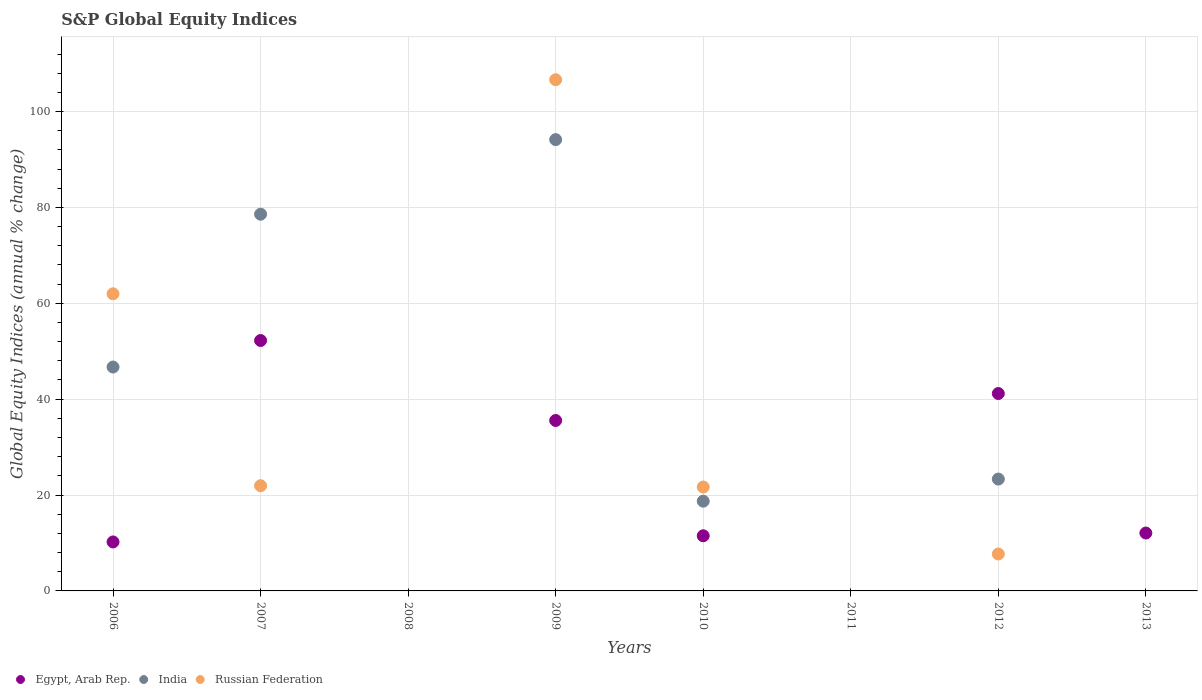Is the number of dotlines equal to the number of legend labels?
Offer a very short reply. No. What is the global equity indices in Russian Federation in 2007?
Give a very brief answer. 21.94. Across all years, what is the maximum global equity indices in Russian Federation?
Ensure brevity in your answer.  106.63. What is the total global equity indices in India in the graph?
Your answer should be very brief. 261.48. What is the difference between the global equity indices in Egypt, Arab Rep. in 2010 and that in 2012?
Your answer should be compact. -29.68. What is the difference between the global equity indices in Russian Federation in 2011 and the global equity indices in India in 2012?
Offer a terse response. -23.33. What is the average global equity indices in Egypt, Arab Rep. per year?
Your answer should be very brief. 20.35. In the year 2010, what is the difference between the global equity indices in India and global equity indices in Russian Federation?
Offer a terse response. -2.95. What is the ratio of the global equity indices in India in 2006 to that in 2009?
Make the answer very short. 0.5. Is the global equity indices in Egypt, Arab Rep. in 2009 less than that in 2013?
Keep it short and to the point. No. Is the difference between the global equity indices in India in 2006 and 2009 greater than the difference between the global equity indices in Russian Federation in 2006 and 2009?
Offer a very short reply. No. What is the difference between the highest and the second highest global equity indices in Russian Federation?
Give a very brief answer. 44.65. What is the difference between the highest and the lowest global equity indices in Russian Federation?
Ensure brevity in your answer.  106.63. Is the sum of the global equity indices in Egypt, Arab Rep. in 2010 and 2012 greater than the maximum global equity indices in Russian Federation across all years?
Provide a short and direct response. No. Is it the case that in every year, the sum of the global equity indices in India and global equity indices in Russian Federation  is greater than the global equity indices in Egypt, Arab Rep.?
Offer a very short reply. No. Is the global equity indices in Egypt, Arab Rep. strictly greater than the global equity indices in India over the years?
Offer a terse response. No. Is the global equity indices in India strictly less than the global equity indices in Egypt, Arab Rep. over the years?
Offer a terse response. No. How many dotlines are there?
Make the answer very short. 3. How many years are there in the graph?
Keep it short and to the point. 8. What is the difference between two consecutive major ticks on the Y-axis?
Give a very brief answer. 20. Are the values on the major ticks of Y-axis written in scientific E-notation?
Provide a succinct answer. No. Does the graph contain any zero values?
Ensure brevity in your answer.  Yes. How many legend labels are there?
Keep it short and to the point. 3. What is the title of the graph?
Offer a terse response. S&P Global Equity Indices. Does "Zambia" appear as one of the legend labels in the graph?
Make the answer very short. No. What is the label or title of the Y-axis?
Your answer should be very brief. Global Equity Indices (annual % change). What is the Global Equity Indices (annual % change) in Egypt, Arab Rep. in 2006?
Your response must be concise. 10.22. What is the Global Equity Indices (annual % change) in India in 2006?
Make the answer very short. 46.7. What is the Global Equity Indices (annual % change) in Russian Federation in 2006?
Provide a short and direct response. 61.98. What is the Global Equity Indices (annual % change) of Egypt, Arab Rep. in 2007?
Give a very brief answer. 52.24. What is the Global Equity Indices (annual % change) of India in 2007?
Offer a very short reply. 78.58. What is the Global Equity Indices (annual % change) of Russian Federation in 2007?
Offer a very short reply. 21.94. What is the Global Equity Indices (annual % change) in India in 2008?
Make the answer very short. 0. What is the Global Equity Indices (annual % change) in Egypt, Arab Rep. in 2009?
Ensure brevity in your answer.  35.55. What is the Global Equity Indices (annual % change) in India in 2009?
Your answer should be very brief. 94.14. What is the Global Equity Indices (annual % change) in Russian Federation in 2009?
Give a very brief answer. 106.63. What is the Global Equity Indices (annual % change) of Egypt, Arab Rep. in 2010?
Provide a short and direct response. 11.5. What is the Global Equity Indices (annual % change) of India in 2010?
Your response must be concise. 18.72. What is the Global Equity Indices (annual % change) in Russian Federation in 2010?
Give a very brief answer. 21.67. What is the Global Equity Indices (annual % change) in India in 2011?
Ensure brevity in your answer.  0. What is the Global Equity Indices (annual % change) in Egypt, Arab Rep. in 2012?
Offer a very short reply. 41.18. What is the Global Equity Indices (annual % change) in India in 2012?
Your response must be concise. 23.33. What is the Global Equity Indices (annual % change) of Russian Federation in 2012?
Give a very brief answer. 7.7. What is the Global Equity Indices (annual % change) of Egypt, Arab Rep. in 2013?
Offer a terse response. 12.08. What is the Global Equity Indices (annual % change) of India in 2013?
Give a very brief answer. 0. Across all years, what is the maximum Global Equity Indices (annual % change) of Egypt, Arab Rep.?
Offer a terse response. 52.24. Across all years, what is the maximum Global Equity Indices (annual % change) in India?
Provide a succinct answer. 94.14. Across all years, what is the maximum Global Equity Indices (annual % change) of Russian Federation?
Provide a short and direct response. 106.63. Across all years, what is the minimum Global Equity Indices (annual % change) of India?
Provide a short and direct response. 0. Across all years, what is the minimum Global Equity Indices (annual % change) in Russian Federation?
Ensure brevity in your answer.  0. What is the total Global Equity Indices (annual % change) of Egypt, Arab Rep. in the graph?
Your answer should be compact. 162.77. What is the total Global Equity Indices (annual % change) in India in the graph?
Provide a short and direct response. 261.48. What is the total Global Equity Indices (annual % change) in Russian Federation in the graph?
Your answer should be compact. 219.93. What is the difference between the Global Equity Indices (annual % change) of Egypt, Arab Rep. in 2006 and that in 2007?
Ensure brevity in your answer.  -42.02. What is the difference between the Global Equity Indices (annual % change) of India in 2006 and that in 2007?
Keep it short and to the point. -31.88. What is the difference between the Global Equity Indices (annual % change) in Russian Federation in 2006 and that in 2007?
Offer a terse response. 40.04. What is the difference between the Global Equity Indices (annual % change) of Egypt, Arab Rep. in 2006 and that in 2009?
Give a very brief answer. -25.34. What is the difference between the Global Equity Indices (annual % change) of India in 2006 and that in 2009?
Make the answer very short. -47.44. What is the difference between the Global Equity Indices (annual % change) in Russian Federation in 2006 and that in 2009?
Your answer should be very brief. -44.65. What is the difference between the Global Equity Indices (annual % change) of Egypt, Arab Rep. in 2006 and that in 2010?
Your response must be concise. -1.28. What is the difference between the Global Equity Indices (annual % change) in India in 2006 and that in 2010?
Your answer should be very brief. 27.98. What is the difference between the Global Equity Indices (annual % change) in Russian Federation in 2006 and that in 2010?
Offer a very short reply. 40.31. What is the difference between the Global Equity Indices (annual % change) in Egypt, Arab Rep. in 2006 and that in 2012?
Provide a succinct answer. -30.96. What is the difference between the Global Equity Indices (annual % change) of India in 2006 and that in 2012?
Keep it short and to the point. 23.37. What is the difference between the Global Equity Indices (annual % change) of Russian Federation in 2006 and that in 2012?
Offer a terse response. 54.28. What is the difference between the Global Equity Indices (annual % change) of Egypt, Arab Rep. in 2006 and that in 2013?
Provide a succinct answer. -1.86. What is the difference between the Global Equity Indices (annual % change) of Egypt, Arab Rep. in 2007 and that in 2009?
Ensure brevity in your answer.  16.68. What is the difference between the Global Equity Indices (annual % change) of India in 2007 and that in 2009?
Make the answer very short. -15.56. What is the difference between the Global Equity Indices (annual % change) in Russian Federation in 2007 and that in 2009?
Offer a very short reply. -84.69. What is the difference between the Global Equity Indices (annual % change) of Egypt, Arab Rep. in 2007 and that in 2010?
Keep it short and to the point. 40.74. What is the difference between the Global Equity Indices (annual % change) in India in 2007 and that in 2010?
Your answer should be very brief. 59.86. What is the difference between the Global Equity Indices (annual % change) in Russian Federation in 2007 and that in 2010?
Keep it short and to the point. 0.27. What is the difference between the Global Equity Indices (annual % change) of Egypt, Arab Rep. in 2007 and that in 2012?
Make the answer very short. 11.06. What is the difference between the Global Equity Indices (annual % change) of India in 2007 and that in 2012?
Keep it short and to the point. 55.25. What is the difference between the Global Equity Indices (annual % change) in Russian Federation in 2007 and that in 2012?
Offer a very short reply. 14.24. What is the difference between the Global Equity Indices (annual % change) in Egypt, Arab Rep. in 2007 and that in 2013?
Your response must be concise. 40.16. What is the difference between the Global Equity Indices (annual % change) of Egypt, Arab Rep. in 2009 and that in 2010?
Offer a terse response. 24.05. What is the difference between the Global Equity Indices (annual % change) of India in 2009 and that in 2010?
Your answer should be very brief. 75.42. What is the difference between the Global Equity Indices (annual % change) of Russian Federation in 2009 and that in 2010?
Offer a terse response. 84.96. What is the difference between the Global Equity Indices (annual % change) in Egypt, Arab Rep. in 2009 and that in 2012?
Ensure brevity in your answer.  -5.62. What is the difference between the Global Equity Indices (annual % change) of India in 2009 and that in 2012?
Offer a very short reply. 70.81. What is the difference between the Global Equity Indices (annual % change) in Russian Federation in 2009 and that in 2012?
Ensure brevity in your answer.  98.93. What is the difference between the Global Equity Indices (annual % change) in Egypt, Arab Rep. in 2009 and that in 2013?
Your answer should be very brief. 23.48. What is the difference between the Global Equity Indices (annual % change) of Egypt, Arab Rep. in 2010 and that in 2012?
Keep it short and to the point. -29.68. What is the difference between the Global Equity Indices (annual % change) in India in 2010 and that in 2012?
Offer a very short reply. -4.61. What is the difference between the Global Equity Indices (annual % change) of Russian Federation in 2010 and that in 2012?
Offer a very short reply. 13.97. What is the difference between the Global Equity Indices (annual % change) of Egypt, Arab Rep. in 2010 and that in 2013?
Make the answer very short. -0.58. What is the difference between the Global Equity Indices (annual % change) in Egypt, Arab Rep. in 2012 and that in 2013?
Offer a very short reply. 29.1. What is the difference between the Global Equity Indices (annual % change) in Egypt, Arab Rep. in 2006 and the Global Equity Indices (annual % change) in India in 2007?
Offer a very short reply. -68.36. What is the difference between the Global Equity Indices (annual % change) of Egypt, Arab Rep. in 2006 and the Global Equity Indices (annual % change) of Russian Federation in 2007?
Provide a short and direct response. -11.73. What is the difference between the Global Equity Indices (annual % change) of India in 2006 and the Global Equity Indices (annual % change) of Russian Federation in 2007?
Make the answer very short. 24.76. What is the difference between the Global Equity Indices (annual % change) in Egypt, Arab Rep. in 2006 and the Global Equity Indices (annual % change) in India in 2009?
Make the answer very short. -83.92. What is the difference between the Global Equity Indices (annual % change) in Egypt, Arab Rep. in 2006 and the Global Equity Indices (annual % change) in Russian Federation in 2009?
Offer a very short reply. -96.42. What is the difference between the Global Equity Indices (annual % change) in India in 2006 and the Global Equity Indices (annual % change) in Russian Federation in 2009?
Provide a short and direct response. -59.93. What is the difference between the Global Equity Indices (annual % change) of Egypt, Arab Rep. in 2006 and the Global Equity Indices (annual % change) of India in 2010?
Offer a terse response. -8.51. What is the difference between the Global Equity Indices (annual % change) in Egypt, Arab Rep. in 2006 and the Global Equity Indices (annual % change) in Russian Federation in 2010?
Make the answer very short. -11.46. What is the difference between the Global Equity Indices (annual % change) of India in 2006 and the Global Equity Indices (annual % change) of Russian Federation in 2010?
Your response must be concise. 25.03. What is the difference between the Global Equity Indices (annual % change) in Egypt, Arab Rep. in 2006 and the Global Equity Indices (annual % change) in India in 2012?
Ensure brevity in your answer.  -13.11. What is the difference between the Global Equity Indices (annual % change) of Egypt, Arab Rep. in 2006 and the Global Equity Indices (annual % change) of Russian Federation in 2012?
Your answer should be compact. 2.52. What is the difference between the Global Equity Indices (annual % change) of India in 2006 and the Global Equity Indices (annual % change) of Russian Federation in 2012?
Make the answer very short. 39. What is the difference between the Global Equity Indices (annual % change) in Egypt, Arab Rep. in 2007 and the Global Equity Indices (annual % change) in India in 2009?
Your response must be concise. -41.9. What is the difference between the Global Equity Indices (annual % change) in Egypt, Arab Rep. in 2007 and the Global Equity Indices (annual % change) in Russian Federation in 2009?
Keep it short and to the point. -54.39. What is the difference between the Global Equity Indices (annual % change) of India in 2007 and the Global Equity Indices (annual % change) of Russian Federation in 2009?
Provide a short and direct response. -28.05. What is the difference between the Global Equity Indices (annual % change) of Egypt, Arab Rep. in 2007 and the Global Equity Indices (annual % change) of India in 2010?
Ensure brevity in your answer.  33.52. What is the difference between the Global Equity Indices (annual % change) of Egypt, Arab Rep. in 2007 and the Global Equity Indices (annual % change) of Russian Federation in 2010?
Make the answer very short. 30.56. What is the difference between the Global Equity Indices (annual % change) in India in 2007 and the Global Equity Indices (annual % change) in Russian Federation in 2010?
Your answer should be compact. 56.91. What is the difference between the Global Equity Indices (annual % change) of Egypt, Arab Rep. in 2007 and the Global Equity Indices (annual % change) of India in 2012?
Provide a short and direct response. 28.91. What is the difference between the Global Equity Indices (annual % change) in Egypt, Arab Rep. in 2007 and the Global Equity Indices (annual % change) in Russian Federation in 2012?
Keep it short and to the point. 44.54. What is the difference between the Global Equity Indices (annual % change) of India in 2007 and the Global Equity Indices (annual % change) of Russian Federation in 2012?
Make the answer very short. 70.88. What is the difference between the Global Equity Indices (annual % change) of Egypt, Arab Rep. in 2009 and the Global Equity Indices (annual % change) of India in 2010?
Ensure brevity in your answer.  16.83. What is the difference between the Global Equity Indices (annual % change) in Egypt, Arab Rep. in 2009 and the Global Equity Indices (annual % change) in Russian Federation in 2010?
Offer a very short reply. 13.88. What is the difference between the Global Equity Indices (annual % change) of India in 2009 and the Global Equity Indices (annual % change) of Russian Federation in 2010?
Make the answer very short. 72.47. What is the difference between the Global Equity Indices (annual % change) in Egypt, Arab Rep. in 2009 and the Global Equity Indices (annual % change) in India in 2012?
Your answer should be compact. 12.22. What is the difference between the Global Equity Indices (annual % change) of Egypt, Arab Rep. in 2009 and the Global Equity Indices (annual % change) of Russian Federation in 2012?
Offer a very short reply. 27.85. What is the difference between the Global Equity Indices (annual % change) of India in 2009 and the Global Equity Indices (annual % change) of Russian Federation in 2012?
Ensure brevity in your answer.  86.44. What is the difference between the Global Equity Indices (annual % change) in Egypt, Arab Rep. in 2010 and the Global Equity Indices (annual % change) in India in 2012?
Your response must be concise. -11.83. What is the difference between the Global Equity Indices (annual % change) of Egypt, Arab Rep. in 2010 and the Global Equity Indices (annual % change) of Russian Federation in 2012?
Provide a succinct answer. 3.8. What is the difference between the Global Equity Indices (annual % change) of India in 2010 and the Global Equity Indices (annual % change) of Russian Federation in 2012?
Make the answer very short. 11.02. What is the average Global Equity Indices (annual % change) in Egypt, Arab Rep. per year?
Provide a succinct answer. 20.35. What is the average Global Equity Indices (annual % change) of India per year?
Provide a short and direct response. 32.68. What is the average Global Equity Indices (annual % change) of Russian Federation per year?
Make the answer very short. 27.49. In the year 2006, what is the difference between the Global Equity Indices (annual % change) of Egypt, Arab Rep. and Global Equity Indices (annual % change) of India?
Your response must be concise. -36.48. In the year 2006, what is the difference between the Global Equity Indices (annual % change) of Egypt, Arab Rep. and Global Equity Indices (annual % change) of Russian Federation?
Offer a terse response. -51.76. In the year 2006, what is the difference between the Global Equity Indices (annual % change) of India and Global Equity Indices (annual % change) of Russian Federation?
Give a very brief answer. -15.28. In the year 2007, what is the difference between the Global Equity Indices (annual % change) of Egypt, Arab Rep. and Global Equity Indices (annual % change) of India?
Your answer should be compact. -26.34. In the year 2007, what is the difference between the Global Equity Indices (annual % change) in Egypt, Arab Rep. and Global Equity Indices (annual % change) in Russian Federation?
Your answer should be compact. 30.3. In the year 2007, what is the difference between the Global Equity Indices (annual % change) in India and Global Equity Indices (annual % change) in Russian Federation?
Keep it short and to the point. 56.64. In the year 2009, what is the difference between the Global Equity Indices (annual % change) in Egypt, Arab Rep. and Global Equity Indices (annual % change) in India?
Give a very brief answer. -58.59. In the year 2009, what is the difference between the Global Equity Indices (annual % change) of Egypt, Arab Rep. and Global Equity Indices (annual % change) of Russian Federation?
Your answer should be compact. -71.08. In the year 2009, what is the difference between the Global Equity Indices (annual % change) in India and Global Equity Indices (annual % change) in Russian Federation?
Your answer should be compact. -12.49. In the year 2010, what is the difference between the Global Equity Indices (annual % change) in Egypt, Arab Rep. and Global Equity Indices (annual % change) in India?
Keep it short and to the point. -7.22. In the year 2010, what is the difference between the Global Equity Indices (annual % change) in Egypt, Arab Rep. and Global Equity Indices (annual % change) in Russian Federation?
Your response must be concise. -10.17. In the year 2010, what is the difference between the Global Equity Indices (annual % change) of India and Global Equity Indices (annual % change) of Russian Federation?
Ensure brevity in your answer.  -2.95. In the year 2012, what is the difference between the Global Equity Indices (annual % change) in Egypt, Arab Rep. and Global Equity Indices (annual % change) in India?
Keep it short and to the point. 17.85. In the year 2012, what is the difference between the Global Equity Indices (annual % change) of Egypt, Arab Rep. and Global Equity Indices (annual % change) of Russian Federation?
Keep it short and to the point. 33.48. In the year 2012, what is the difference between the Global Equity Indices (annual % change) of India and Global Equity Indices (annual % change) of Russian Federation?
Provide a short and direct response. 15.63. What is the ratio of the Global Equity Indices (annual % change) of Egypt, Arab Rep. in 2006 to that in 2007?
Give a very brief answer. 0.2. What is the ratio of the Global Equity Indices (annual % change) in India in 2006 to that in 2007?
Ensure brevity in your answer.  0.59. What is the ratio of the Global Equity Indices (annual % change) in Russian Federation in 2006 to that in 2007?
Make the answer very short. 2.82. What is the ratio of the Global Equity Indices (annual % change) in Egypt, Arab Rep. in 2006 to that in 2009?
Keep it short and to the point. 0.29. What is the ratio of the Global Equity Indices (annual % change) of India in 2006 to that in 2009?
Your answer should be very brief. 0.5. What is the ratio of the Global Equity Indices (annual % change) of Russian Federation in 2006 to that in 2009?
Keep it short and to the point. 0.58. What is the ratio of the Global Equity Indices (annual % change) of Egypt, Arab Rep. in 2006 to that in 2010?
Provide a short and direct response. 0.89. What is the ratio of the Global Equity Indices (annual % change) of India in 2006 to that in 2010?
Keep it short and to the point. 2.49. What is the ratio of the Global Equity Indices (annual % change) of Russian Federation in 2006 to that in 2010?
Provide a short and direct response. 2.86. What is the ratio of the Global Equity Indices (annual % change) of Egypt, Arab Rep. in 2006 to that in 2012?
Provide a succinct answer. 0.25. What is the ratio of the Global Equity Indices (annual % change) of India in 2006 to that in 2012?
Your answer should be compact. 2. What is the ratio of the Global Equity Indices (annual % change) in Russian Federation in 2006 to that in 2012?
Your answer should be very brief. 8.05. What is the ratio of the Global Equity Indices (annual % change) of Egypt, Arab Rep. in 2006 to that in 2013?
Provide a short and direct response. 0.85. What is the ratio of the Global Equity Indices (annual % change) in Egypt, Arab Rep. in 2007 to that in 2009?
Offer a very short reply. 1.47. What is the ratio of the Global Equity Indices (annual % change) of India in 2007 to that in 2009?
Your response must be concise. 0.83. What is the ratio of the Global Equity Indices (annual % change) in Russian Federation in 2007 to that in 2009?
Ensure brevity in your answer.  0.21. What is the ratio of the Global Equity Indices (annual % change) of Egypt, Arab Rep. in 2007 to that in 2010?
Your response must be concise. 4.54. What is the ratio of the Global Equity Indices (annual % change) in India in 2007 to that in 2010?
Give a very brief answer. 4.2. What is the ratio of the Global Equity Indices (annual % change) in Russian Federation in 2007 to that in 2010?
Keep it short and to the point. 1.01. What is the ratio of the Global Equity Indices (annual % change) in Egypt, Arab Rep. in 2007 to that in 2012?
Make the answer very short. 1.27. What is the ratio of the Global Equity Indices (annual % change) in India in 2007 to that in 2012?
Offer a terse response. 3.37. What is the ratio of the Global Equity Indices (annual % change) in Russian Federation in 2007 to that in 2012?
Give a very brief answer. 2.85. What is the ratio of the Global Equity Indices (annual % change) of Egypt, Arab Rep. in 2007 to that in 2013?
Make the answer very short. 4.33. What is the ratio of the Global Equity Indices (annual % change) in Egypt, Arab Rep. in 2009 to that in 2010?
Provide a succinct answer. 3.09. What is the ratio of the Global Equity Indices (annual % change) in India in 2009 to that in 2010?
Provide a short and direct response. 5.03. What is the ratio of the Global Equity Indices (annual % change) of Russian Federation in 2009 to that in 2010?
Offer a terse response. 4.92. What is the ratio of the Global Equity Indices (annual % change) in Egypt, Arab Rep. in 2009 to that in 2012?
Your answer should be compact. 0.86. What is the ratio of the Global Equity Indices (annual % change) of India in 2009 to that in 2012?
Provide a succinct answer. 4.03. What is the ratio of the Global Equity Indices (annual % change) of Russian Federation in 2009 to that in 2012?
Give a very brief answer. 13.84. What is the ratio of the Global Equity Indices (annual % change) of Egypt, Arab Rep. in 2009 to that in 2013?
Offer a very short reply. 2.94. What is the ratio of the Global Equity Indices (annual % change) in Egypt, Arab Rep. in 2010 to that in 2012?
Your answer should be very brief. 0.28. What is the ratio of the Global Equity Indices (annual % change) in India in 2010 to that in 2012?
Provide a short and direct response. 0.8. What is the ratio of the Global Equity Indices (annual % change) in Russian Federation in 2010 to that in 2012?
Provide a short and direct response. 2.81. What is the ratio of the Global Equity Indices (annual % change) in Egypt, Arab Rep. in 2010 to that in 2013?
Keep it short and to the point. 0.95. What is the ratio of the Global Equity Indices (annual % change) of Egypt, Arab Rep. in 2012 to that in 2013?
Give a very brief answer. 3.41. What is the difference between the highest and the second highest Global Equity Indices (annual % change) of Egypt, Arab Rep.?
Provide a succinct answer. 11.06. What is the difference between the highest and the second highest Global Equity Indices (annual % change) in India?
Make the answer very short. 15.56. What is the difference between the highest and the second highest Global Equity Indices (annual % change) of Russian Federation?
Ensure brevity in your answer.  44.65. What is the difference between the highest and the lowest Global Equity Indices (annual % change) of Egypt, Arab Rep.?
Offer a very short reply. 52.24. What is the difference between the highest and the lowest Global Equity Indices (annual % change) of India?
Provide a short and direct response. 94.14. What is the difference between the highest and the lowest Global Equity Indices (annual % change) of Russian Federation?
Your answer should be compact. 106.63. 